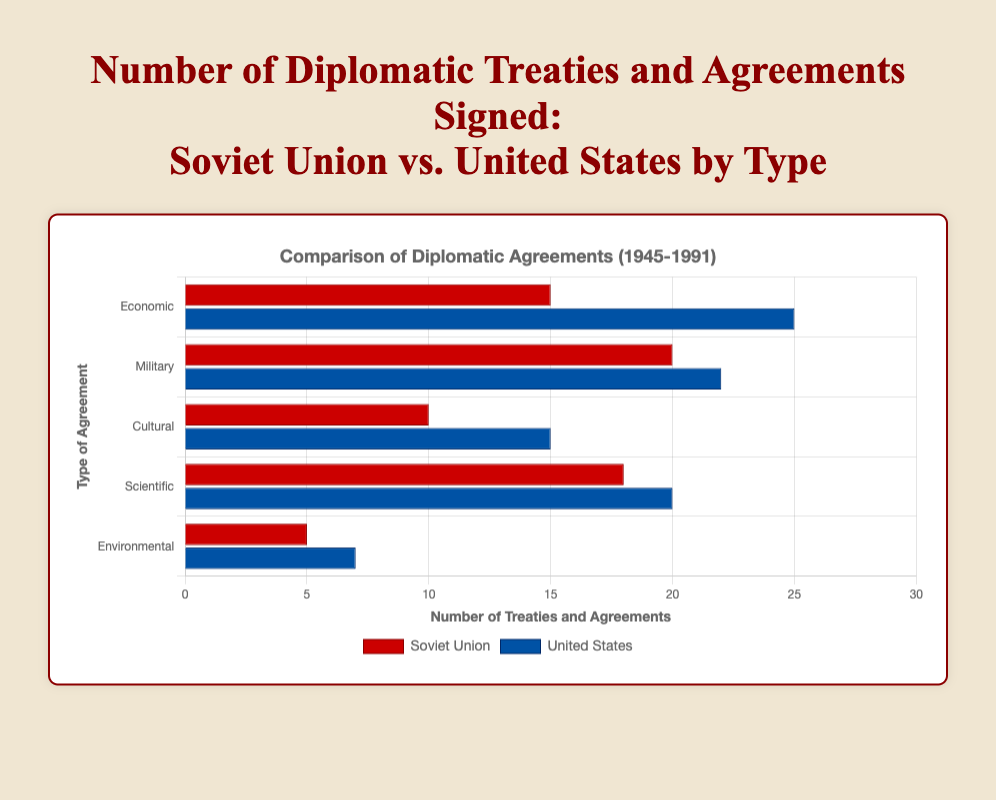Which country signed more Economic treaties? The United States signed 25 Economic treaties while the Soviet Union signed 15. Therefore, the United States signed more Economic treaties.
Answer: The United States Which category of treaties had the largest difference in the number signed between the Soviet Union and the United States? The Economic category had a difference of 10 treaties (25 for the United States minus 15 for the Soviet Union), which is the largest difference when compared to other categories.
Answer: Economic What is the sum of Military and Cultural treaties signed by the Soviet Union? The Soviet Union signed 20 Military treaties and 10 Cultural treaties, so the sum is 20 + 10 = 30.
Answer: 30 Comparing Environmental treaties, how many more did the United States sign than the Soviet Union? The United States signed 7 Environmental treaties, while the Soviet Union signed 5. Therefore, the United States signed 2 more Environmental treaties than the Soviet Union.
Answer: 2 Which categories of treaties did the United States sign more of compared to the Soviet Union? The United States signed more treaties in the following categories: Economic (25 vs 15), Military (22 vs 20), Cultural (15 vs 10), Scientific (20 vs 18), and Environmental (7 vs 5).
Answer: Economic, Military, Cultural, Scientific, Environmental What is the average number of Scientific treaties signed by both countries? The Soviet Union signed 18, and the United States signed 20 Scientific treaties. The average is (18 + 20) / 2 = 19.
Answer: 19 Between the United States and the Soviet Union, which country has the smallest number in any treaty category, and what category is it? The smallest number is 5 for the Environmental treaties signed by the Soviet Union.
Answer: Soviet Union, Environmental What is the total number of treaties signed by the Soviet Union across all categories? The Soviet Union signed 15 Economic, 20 Military, 10 Cultural, 18 Scientific, and 5 Environmental treaties. The total is 15 + 20 + 10 + 18 + 5 = 68.
Answer: 68 Which country's bar for Military treaties is taller, and what does this indicate? The United States' bar for Military treaties is taller, indicating that the United States signed more Military treaties (22) compared to the Soviet Union (20).
Answer: United States, United States signed more In which category did the two countries sign the same number or nearly the same number of treaties? In the Scientific category, the Soviet Union signed 18 treaties and the United States signed 20 treaties, which is the closest among all categories.
Answer: Scientific 